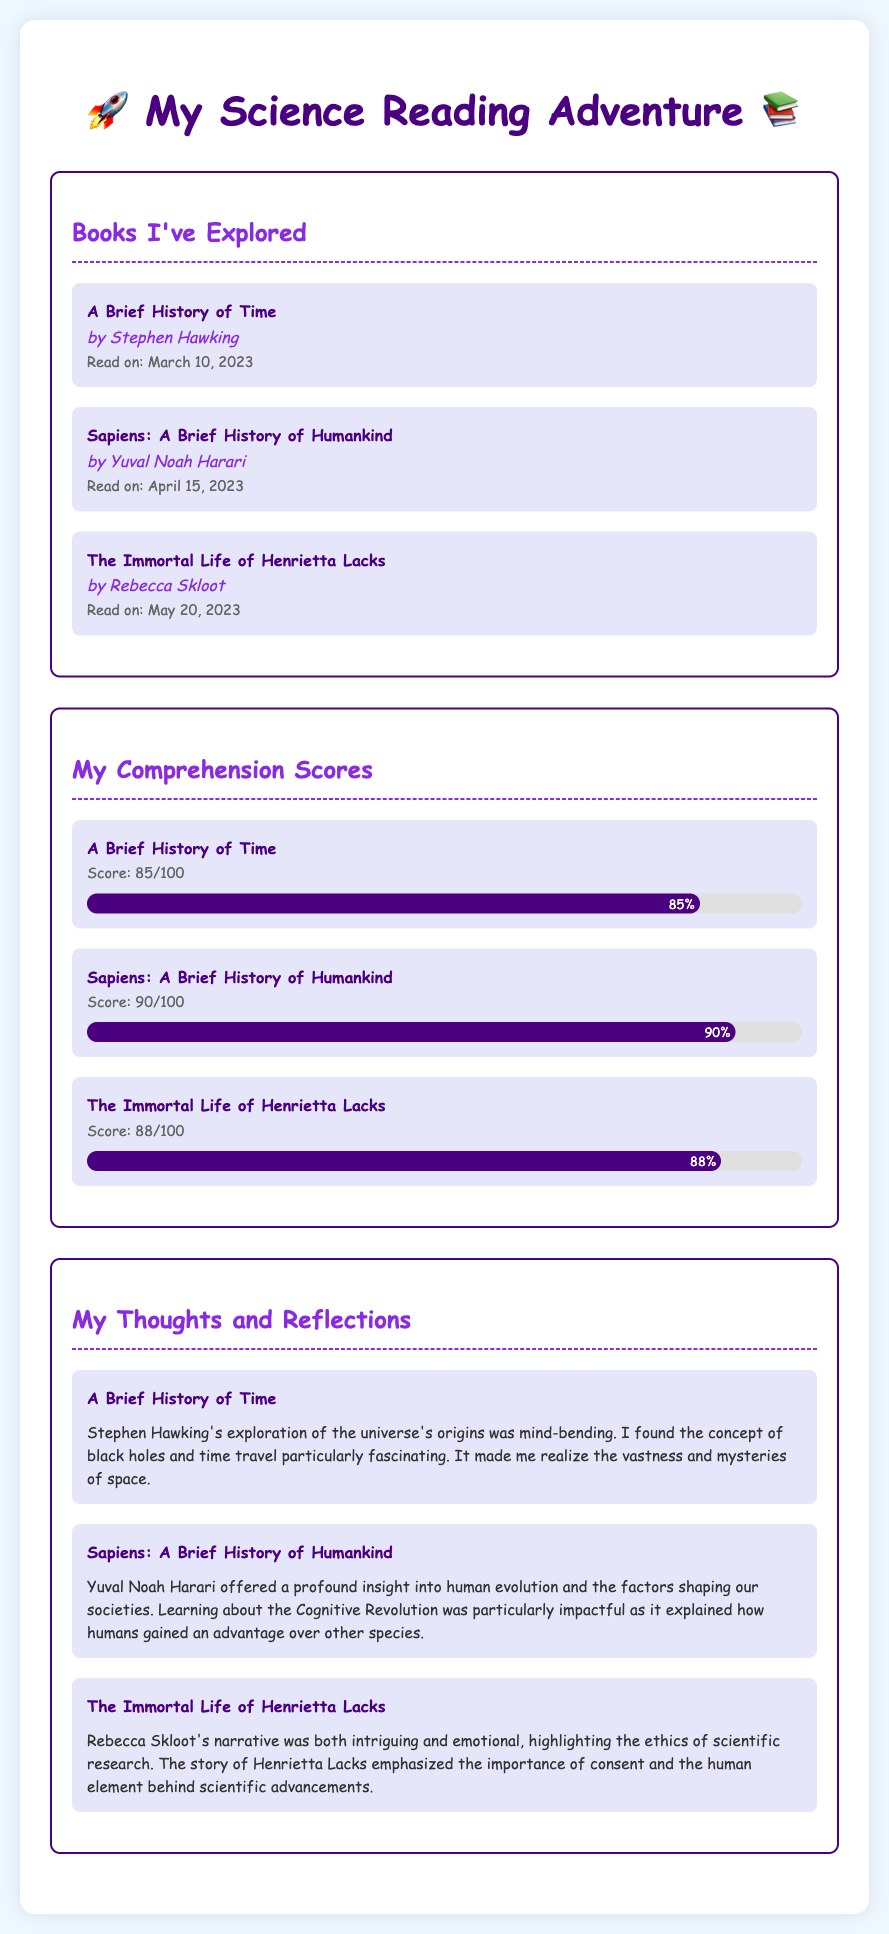What is the title of the first book read? The first book listed under "Books I've Explored" is "A Brief History of Time."
Answer: A Brief History of Time Who is the author of "Sapiens: A Brief History of Humankind"? The author of "Sapiens: A Brief History of Humankind" is Yuval Noah Harari.
Answer: Yuval Noah Harari What score was received for "The Immortal Life of Henrietta Lacks"? The score listed for "The Immortal Life of Henrietta Lacks" is 88 out of 100.
Answer: 88/100 On which date was "A Brief History of Time" read? The reading date for "A Brief History of Time" is March 10, 2023.
Answer: March 10, 2023 Which book had the highest comprehension score? The book with the highest comprehension score is "Sapiens: A Brief History of Humankind" with a score of 90 out of 100.
Answer: Sapiens: A Brief History of Humankind What major topic in "Sapiens" was highlighted as particularly impactful? The document states that learning about the Cognitive Revolution in "Sapiens" was particularly impactful.
Answer: Cognitive Revolution What theme is emphasized in "The Immortal Life of Henrietta Lacks"? The theme emphasized is the ethics of scientific research and the importance of consent.
Answer: Ethics of scientific research How many books are listed in the "Books I've Explored" section? There are three books listed in the "Books I've Explored" section of the document.
Answer: Three 